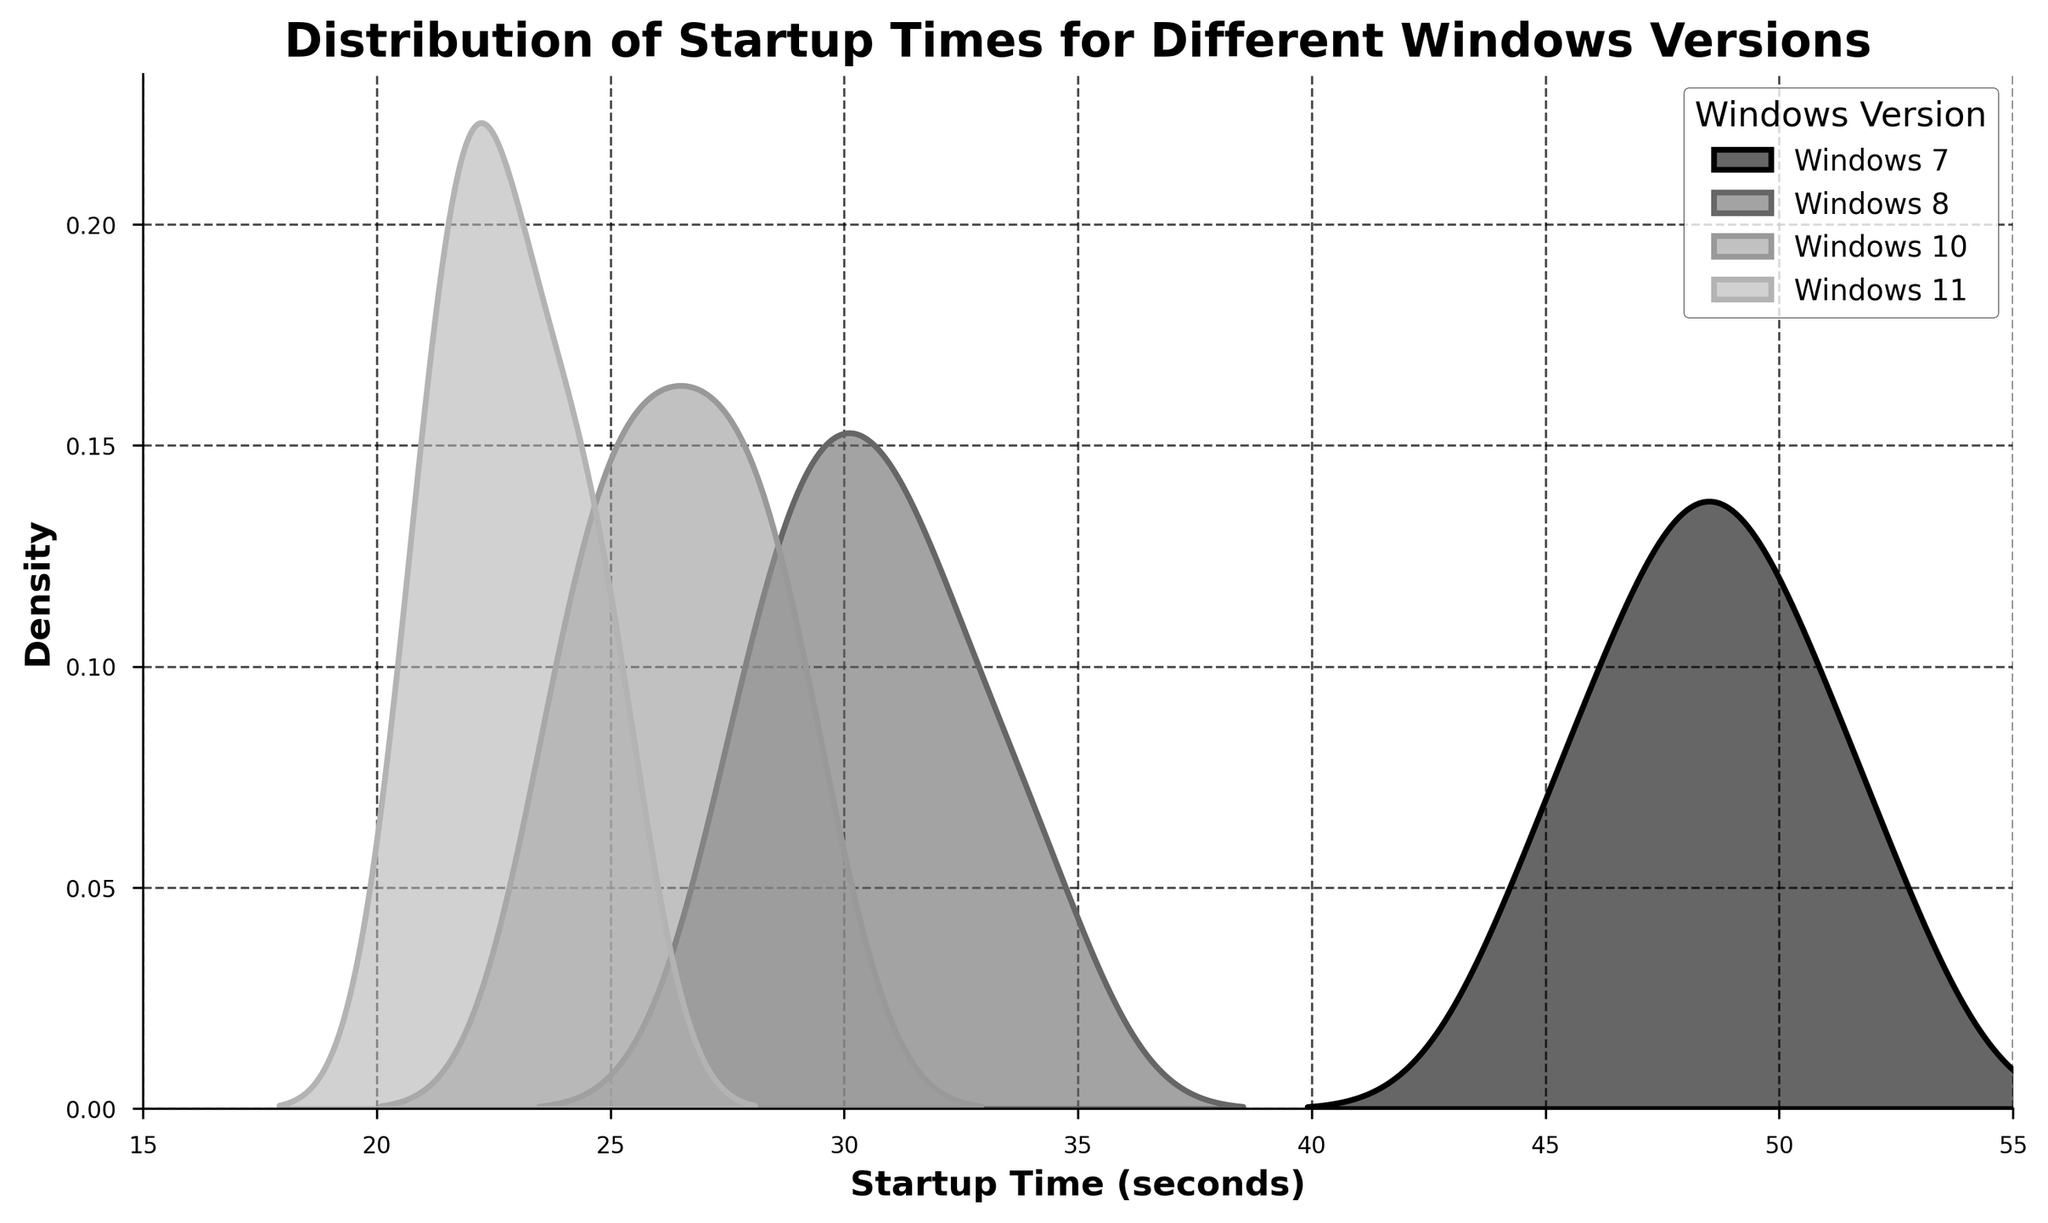What is the title of the density plot? The title of the plot is usually found at the top center and gives an overview of what the figure is about. In this case, the title is clearly indicated.
Answer: Distribution of Startup Times for Different Windows Versions Which Windows version has the lowest density peak for startup times? To determine this, look for the peak of each density curve and identify which one has the lowest vertical height. The lowest peak belongs to Windows 7.
Answer: Windows 7 What is the range of startup times shown on the x-axis? The x-axis displays the range of startup times. It usually has tick marks and labels, which in this figure range from 15 seconds to 55 seconds.
Answer: 15 to 55 seconds Which Windows version has the most concentrated (narrowest) distribution of startup times? A more concentrated distribution will have a steeper, narrower peak compared to more spread-out distributions. Windows 10 has the most concentrated distribution.
Answer: Windows 10 Are there any overlaps in startup times between Windows 8 and Windows 10? To determine overlaps, observe where the shaded density curves of Windows 8 and Windows 10 share space on the x-axis. The overlapping region can be seen around the startup times of 28 to 32 seconds.
Answer: Yes Which Windows version has the shortest average startup time? The average startup time can be inferred by looking at where the density peak is centered. Windows 11 has the peak at the shortest time, around 22-25 seconds.
Answer: Windows 11 Which Windows version shows the widest spread of startup times? The spread of a distribution can be identified by looking at how widely the density curve spreads on the x-axis. Windows 7 has the widest spread, covering a larger range of startup times.
Answer: Windows 7 Between Windows 8 and Windows 11, which version generally starts faster? Comparing the position of the peaks and the overall spread of the curves on the x-axis, Windows 11 has a peak positioned at shorter times than Windows 8.
Answer: Windows 11 What is the approximate density peak height for Windows 10? The density peak height can be observed directly from the plot by noting the highest vertical value of the density curve for Windows 10. It's approximately 0.2.
Answer: 0.2 Which versions of Windows have overlapping startup time densities between 24 and 30 seconds? By inspecting the density curves between the 24 and 30-second marks, we can identify that Windows 8, Windows 10, and Windows 11 have overlapping densities in this interval.
Answer: Windows 8, Windows 10, Windows 11 